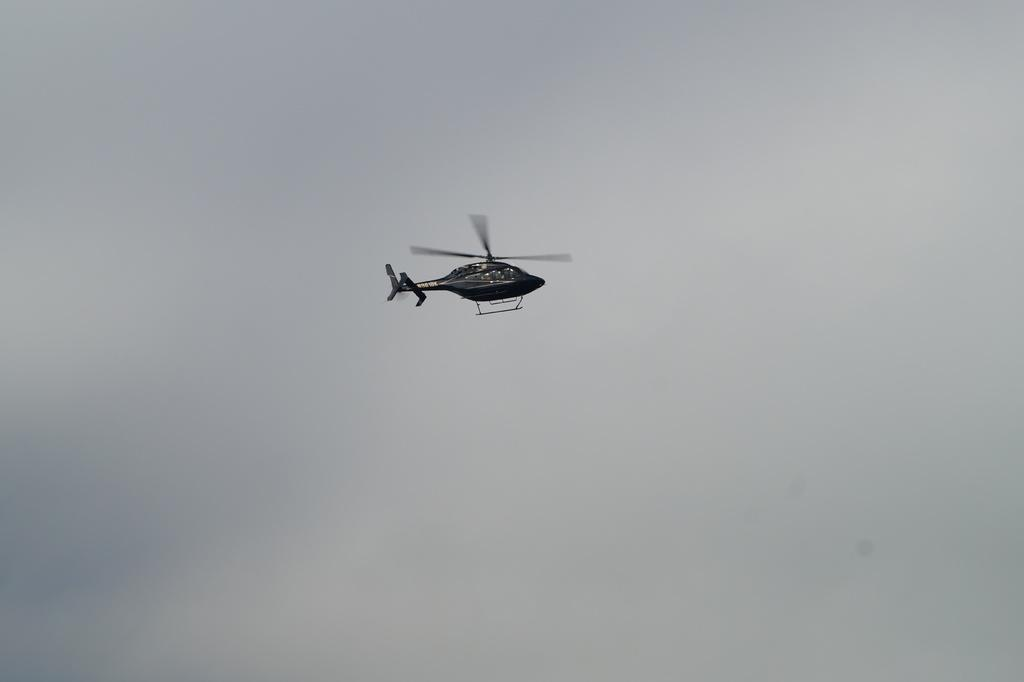What is the main subject of the image? The main subject of the image is a helicopter. What is the helicopter doing in the image? The helicopter is flying in the sky. Can you see a hen flying alongside the helicopter in the image? There is no hen present in the image, and the helicopter is flying alone in the sky. What type of ring can be seen on the pilot's finger in the image? There is no pilot or ring visible in the image; it only features a helicopter flying in the sky. 